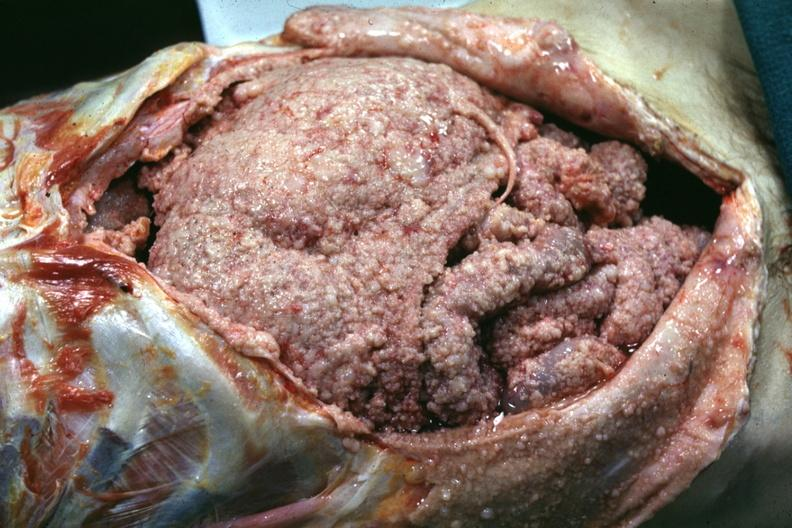does this image show opened abdomen with neoplasm covering all surfaces?
Answer the question using a single word or phrase. Yes 